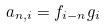Convert formula to latex. <formula><loc_0><loc_0><loc_500><loc_500>a _ { n , i } = f _ { i - n } g _ { i }</formula> 